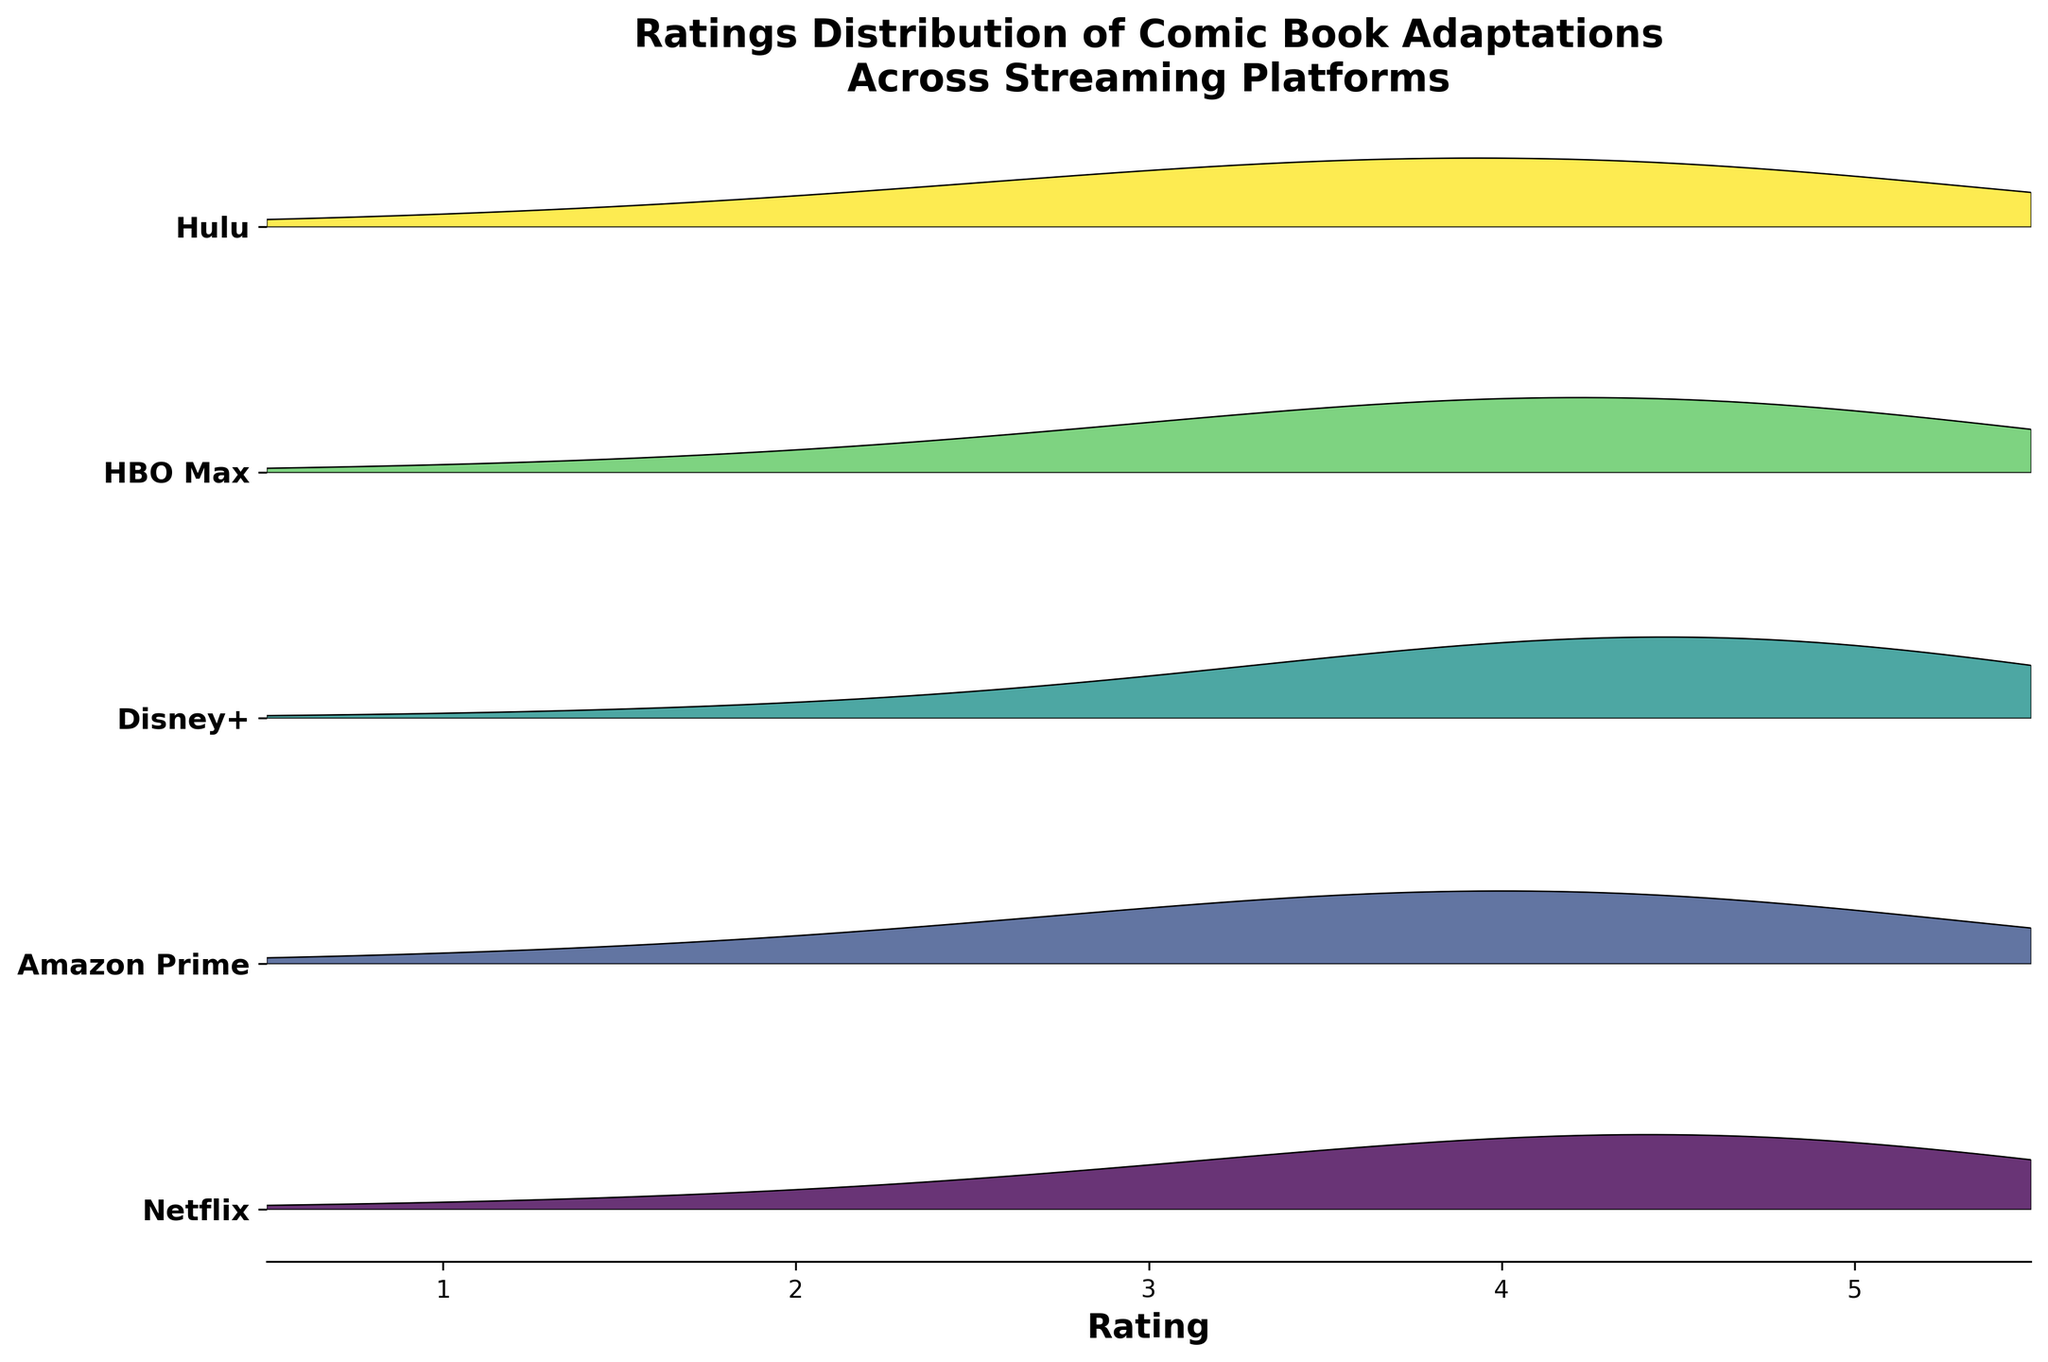what is the title of the plot? The title of the plot appears at the top of the figure.
Answer: Ratings Distribution of Comic Book Adaptations Across Streaming Platforms which streaming platform shows the highest density for rating 5? By examining the highest peaks for rating 5, identify the platform with the tallest peak in the rating 5 region.
Answer: Disney+ what is the range of the x-axis? Look at the x-axis labels and determine the values it spans from the leftmost to the rightmost.
Answer: 0.5 to 5.5 what color represents Hulu in the plot? Identify the layer corresponding to Hulu and observe its color spectrum along the color gradient used in the plot.
Answer: Greenish which streaming platform has the most skewed distribution towards higher ratings? Compare the shapes of the distribution curves and see which one has most of its density towards ratings 4 and 5.
Answer: Disney+ which platform has the lowest density for rating 3? Find which platform has the smallest peak or area under the curve at rating 3.
Answer: Disney+ for which platform does the density climb consistently from ratings 1 to 4? Examine each platform's trend from rating 1 through rating 4 and identify which one shows an increasing pattern.
Answer: Netflix compare the peak densities of Amazon Prime and Netflix for rating 4. Which one is higher? Look at the heights of the density peaks for rating 4 for both Amazon Prime and Netflix and compare their values.
Answer: Amazon Prime which platform has the widest spread in rating densities? Observe the range and spread of densities for each platform to identify the one with the widest spread across different ratings.
Answer: Hulu rank the platforms by density at rating 2, from highest to lowest. Review the height of the density peaks at rating 2 for each platform and rank them in descending order.
Answer: Hulu, Amazon Prime, HBO Max, Netflix, Disney+ 